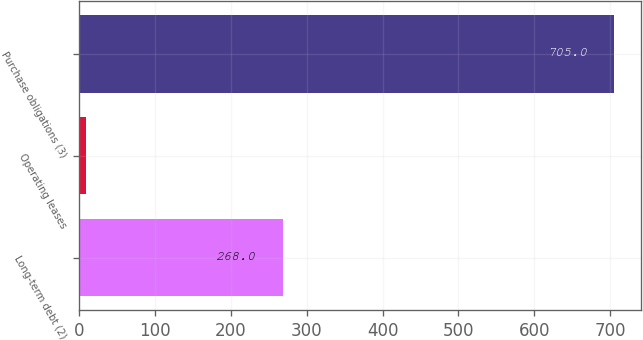Convert chart to OTSL. <chart><loc_0><loc_0><loc_500><loc_500><bar_chart><fcel>Long-term debt (2)<fcel>Operating leases<fcel>Purchase obligations (3)<nl><fcel>268<fcel>8<fcel>705<nl></chart> 